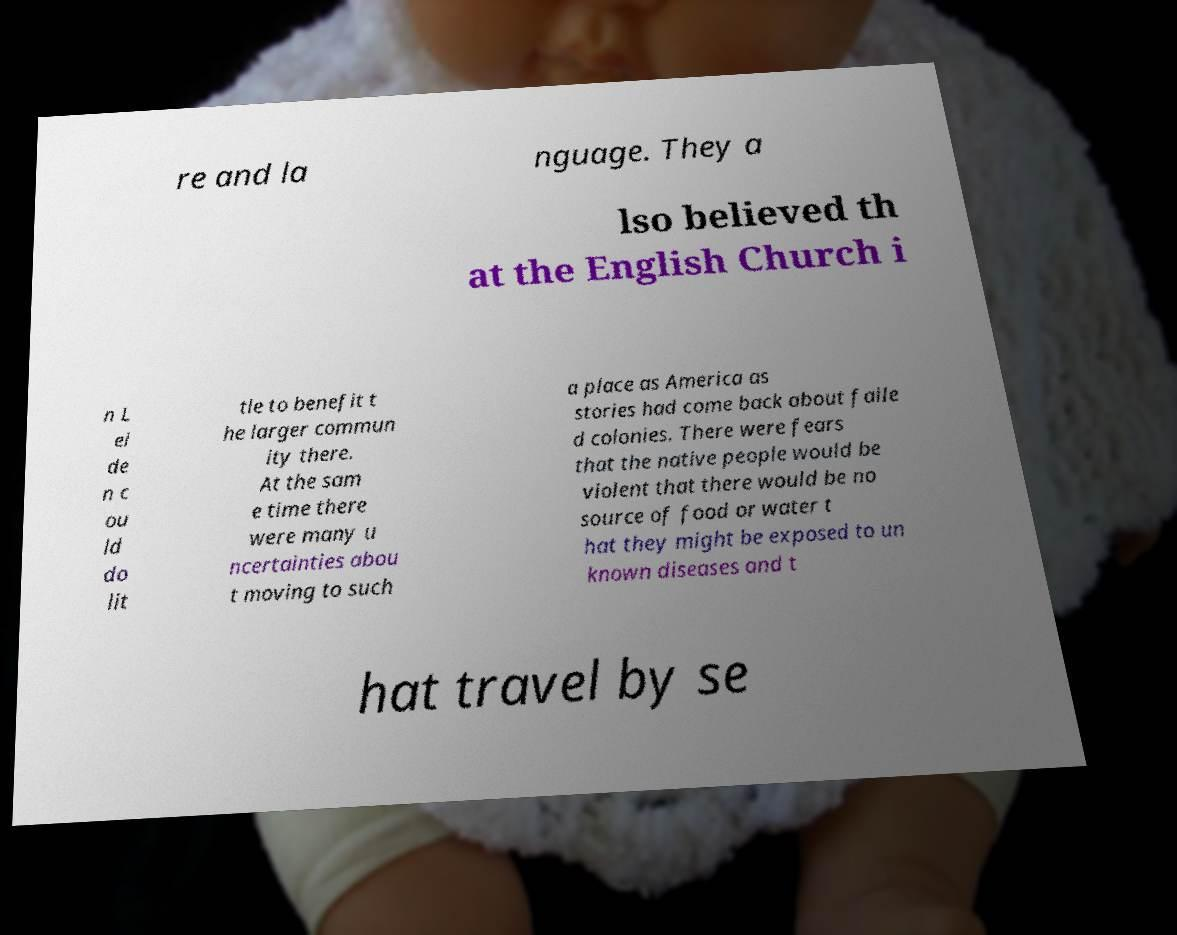For documentation purposes, I need the text within this image transcribed. Could you provide that? re and la nguage. They a lso believed th at the English Church i n L ei de n c ou ld do lit tle to benefit t he larger commun ity there. At the sam e time there were many u ncertainties abou t moving to such a place as America as stories had come back about faile d colonies. There were fears that the native people would be violent that there would be no source of food or water t hat they might be exposed to un known diseases and t hat travel by se 